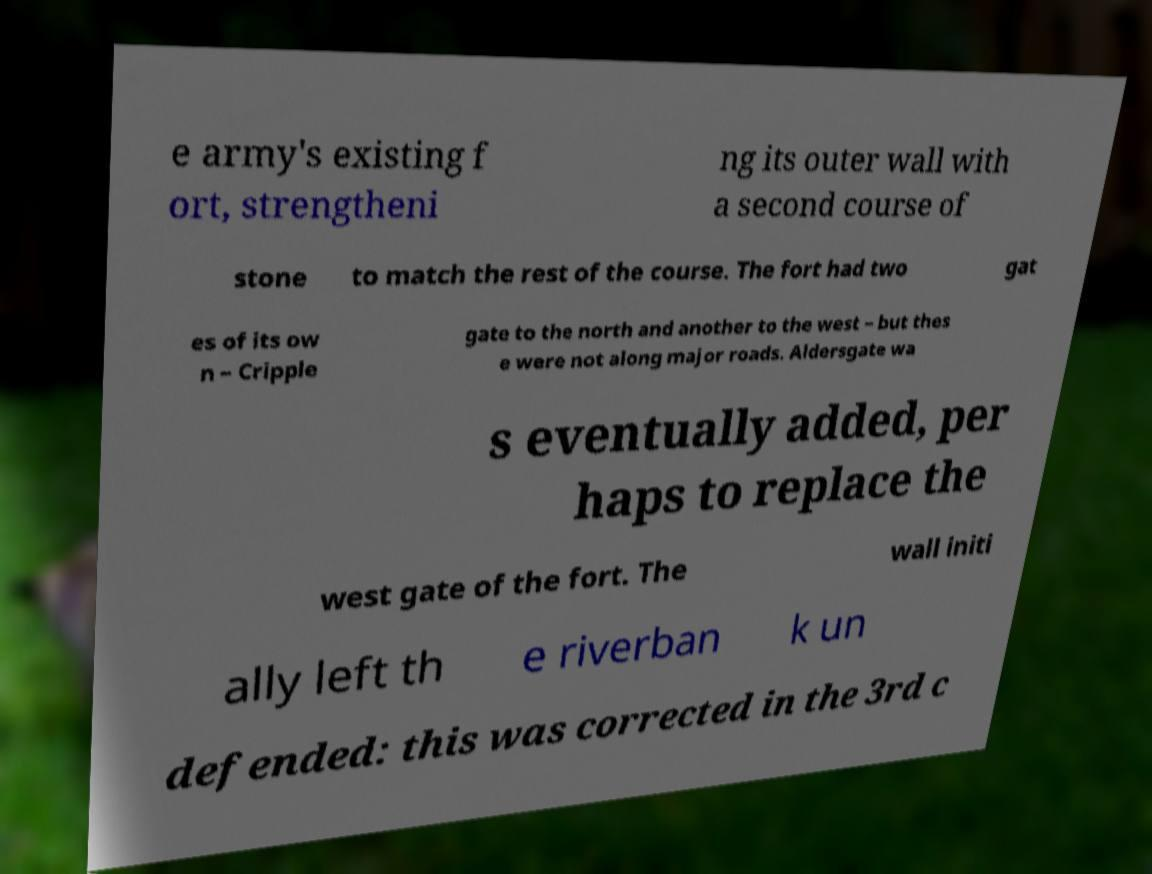I need the written content from this picture converted into text. Can you do that? e army's existing f ort, strengtheni ng its outer wall with a second course of stone to match the rest of the course. The fort had two gat es of its ow n – Cripple gate to the north and another to the west – but thes e were not along major roads. Aldersgate wa s eventually added, per haps to replace the west gate of the fort. The wall initi ally left th e riverban k un defended: this was corrected in the 3rd c 